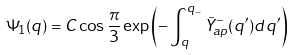<formula> <loc_0><loc_0><loc_500><loc_500>\Psi _ { 1 } ( q ) = C \cos { \frac { \pi } { 3 } } \exp \left ( - \int _ { q } ^ { q _ { - } } \tilde { Y } _ { a p } ^ { - } ( q ^ { \prime } ) d q ^ { \prime } \right )</formula> 